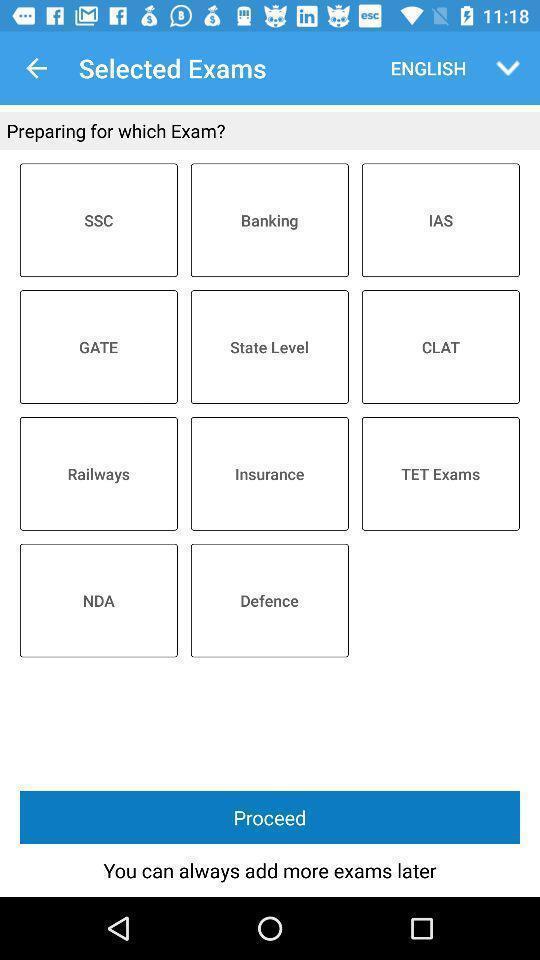Give me a summary of this screen capture. Page showing list of categories on learning app. 